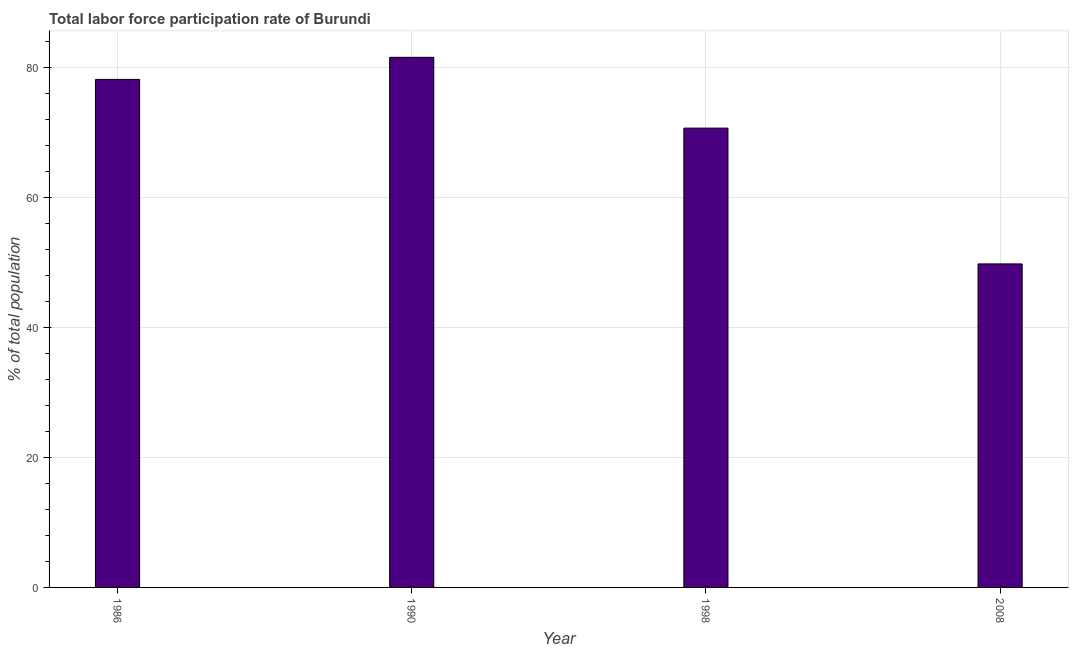Does the graph contain any zero values?
Provide a short and direct response. No. What is the title of the graph?
Provide a short and direct response. Total labor force participation rate of Burundi. What is the label or title of the Y-axis?
Make the answer very short. % of total population. What is the total labor force participation rate in 1998?
Keep it short and to the point. 70.7. Across all years, what is the maximum total labor force participation rate?
Provide a short and direct response. 81.6. Across all years, what is the minimum total labor force participation rate?
Your response must be concise. 49.8. In which year was the total labor force participation rate maximum?
Your answer should be very brief. 1990. In which year was the total labor force participation rate minimum?
Ensure brevity in your answer.  2008. What is the sum of the total labor force participation rate?
Offer a terse response. 280.3. What is the difference between the total labor force participation rate in 1986 and 1990?
Provide a short and direct response. -3.4. What is the average total labor force participation rate per year?
Offer a very short reply. 70.08. What is the median total labor force participation rate?
Give a very brief answer. 74.45. In how many years, is the total labor force participation rate greater than 68 %?
Provide a short and direct response. 3. Do a majority of the years between 1998 and 2008 (inclusive) have total labor force participation rate greater than 64 %?
Give a very brief answer. No. What is the ratio of the total labor force participation rate in 1990 to that in 1998?
Your response must be concise. 1.15. Is the difference between the total labor force participation rate in 1986 and 1990 greater than the difference between any two years?
Offer a terse response. No. What is the difference between the highest and the second highest total labor force participation rate?
Your response must be concise. 3.4. Is the sum of the total labor force participation rate in 1998 and 2008 greater than the maximum total labor force participation rate across all years?
Your response must be concise. Yes. What is the difference between the highest and the lowest total labor force participation rate?
Make the answer very short. 31.8. Are all the bars in the graph horizontal?
Ensure brevity in your answer.  No. What is the % of total population of 1986?
Ensure brevity in your answer.  78.2. What is the % of total population in 1990?
Provide a succinct answer. 81.6. What is the % of total population in 1998?
Your response must be concise. 70.7. What is the % of total population of 2008?
Offer a very short reply. 49.8. What is the difference between the % of total population in 1986 and 1990?
Keep it short and to the point. -3.4. What is the difference between the % of total population in 1986 and 1998?
Keep it short and to the point. 7.5. What is the difference between the % of total population in 1986 and 2008?
Your response must be concise. 28.4. What is the difference between the % of total population in 1990 and 1998?
Offer a very short reply. 10.9. What is the difference between the % of total population in 1990 and 2008?
Your response must be concise. 31.8. What is the difference between the % of total population in 1998 and 2008?
Your response must be concise. 20.9. What is the ratio of the % of total population in 1986 to that in 1990?
Provide a short and direct response. 0.96. What is the ratio of the % of total population in 1986 to that in 1998?
Give a very brief answer. 1.11. What is the ratio of the % of total population in 1986 to that in 2008?
Make the answer very short. 1.57. What is the ratio of the % of total population in 1990 to that in 1998?
Your answer should be very brief. 1.15. What is the ratio of the % of total population in 1990 to that in 2008?
Give a very brief answer. 1.64. What is the ratio of the % of total population in 1998 to that in 2008?
Keep it short and to the point. 1.42. 